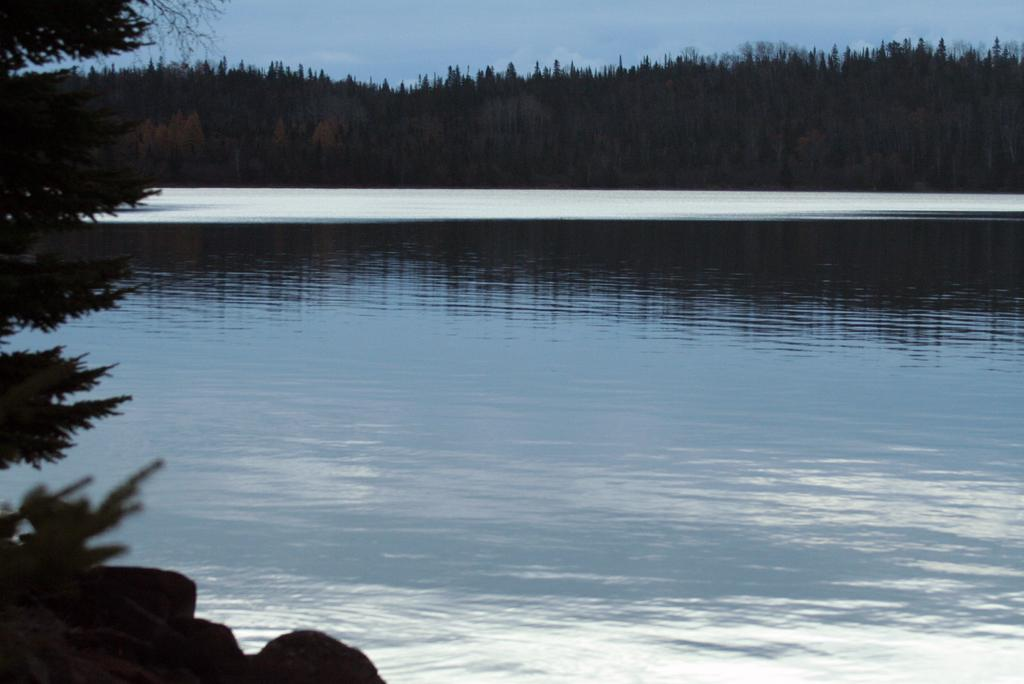What can be seen in the foreground of the image? There is water in the foreground of the image. What elements are present on the left side of the image? There are stones and trees on the left side of the image. What can be seen in the center of the background of the image? There are trees in the center of the background of the image. How would you describe the sky in the image? The sky is cloudy. Can you see a brain in the image? No, there is no brain present in the image. Is there a gun visible in the image? No, there is no gun present in the image. 